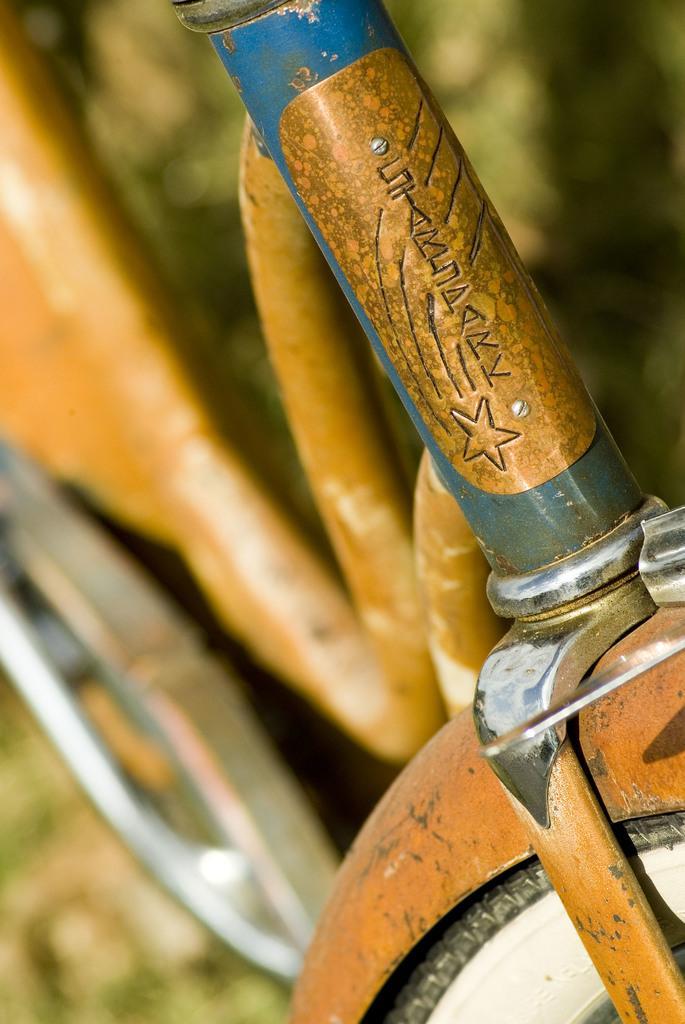How would you summarize this image in a sentence or two? Here in this picture we can see a bicycle present on the ground over there and we can see something written in the front of it over there. 